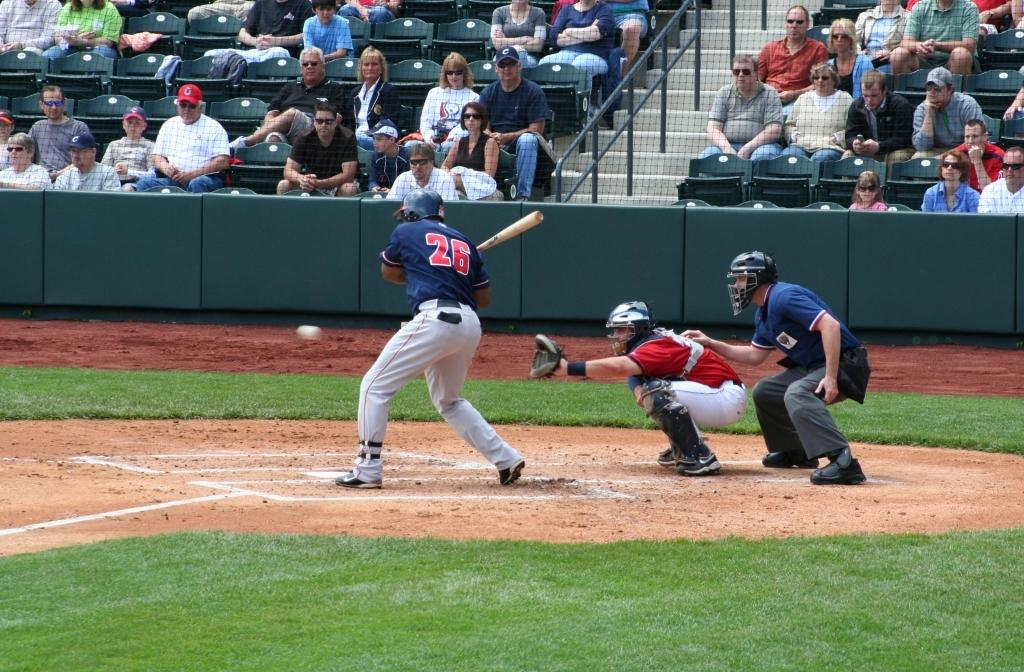<image>
Write a terse but informative summary of the picture. A batter with the number 26 on the back of his shirt. 